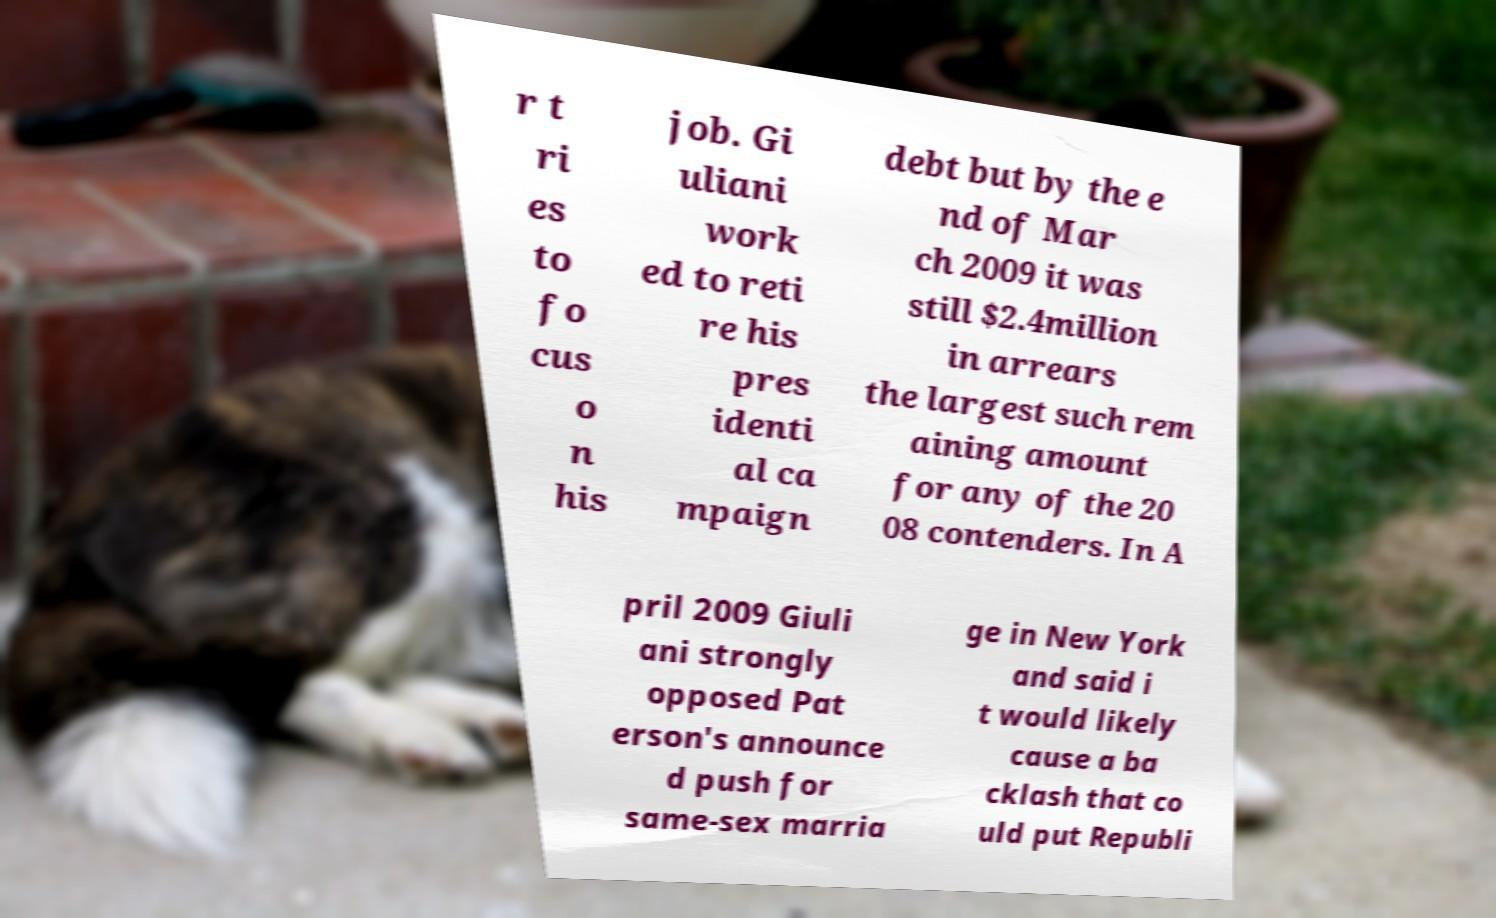What messages or text are displayed in this image? I need them in a readable, typed format. r t ri es to fo cus o n his job. Gi uliani work ed to reti re his pres identi al ca mpaign debt but by the e nd of Mar ch 2009 it was still $2.4million in arrears the largest such rem aining amount for any of the 20 08 contenders. In A pril 2009 Giuli ani strongly opposed Pat erson's announce d push for same-sex marria ge in New York and said i t would likely cause a ba cklash that co uld put Republi 